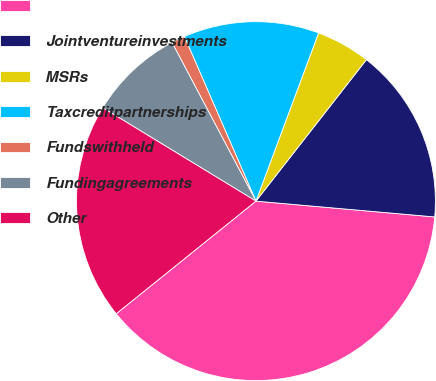Convert chart to OTSL. <chart><loc_0><loc_0><loc_500><loc_500><pie_chart><ecel><fcel>Jointventureinvestments<fcel>MSRs<fcel>Taxcreditpartnerships<fcel>Fundswithheld<fcel>Fundingagreements<fcel>Other<nl><fcel>37.8%<fcel>15.85%<fcel>4.88%<fcel>12.2%<fcel>1.22%<fcel>8.54%<fcel>19.51%<nl></chart> 